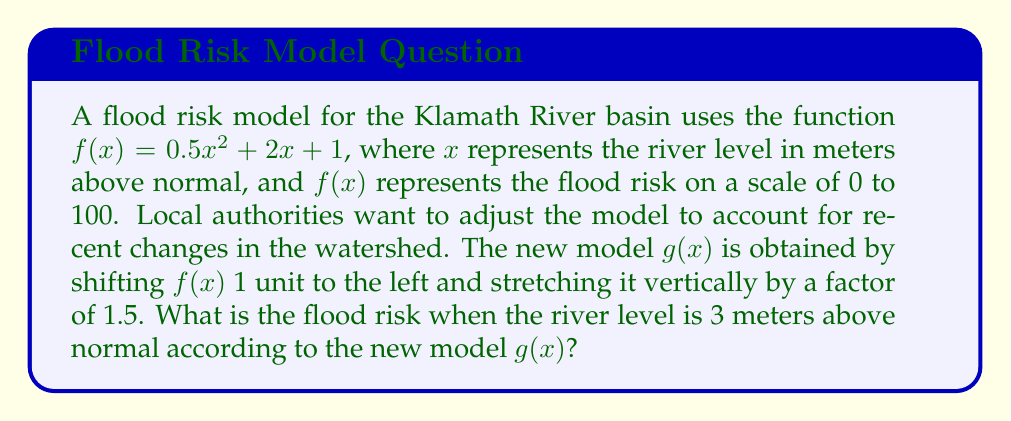Solve this math problem. Let's approach this step-by-step:

1) The original function is $f(x) = 0.5x^2 + 2x + 1$

2) To shift the function 1 unit to the left, we replace $x$ with $(x+1)$:
   $f(x+1) = 0.5(x+1)^2 + 2(x+1) + 1$

3) To stretch it vertically by a factor of 1.5, we multiply the entire function by 1.5:
   $g(x) = 1.5[f(x+1)] = 1.5[0.5(x+1)^2 + 2(x+1) + 1]$

4) Let's expand this:
   $g(x) = 1.5[0.5(x^2 + 2x + 1) + 2x + 2 + 1]$
   $g(x) = 1.5[0.5x^2 + x + 0.5 + 2x + 2 + 1]$
   $g(x) = 1.5[0.5x^2 + 3x + 3.5]$

5) Simplifying:
   $g(x) = 0.75x^2 + 4.5x + 5.25$

6) Now, we need to find $g(3)$:
   $g(3) = 0.75(3)^2 + 4.5(3) + 5.25$
   $g(3) = 0.75(9) + 13.5 + 5.25$
   $g(3) = 6.75 + 13.5 + 5.25$
   $g(3) = 25.5$

Therefore, when the river level is 3 meters above normal, the flood risk according to the new model is 25.5 on a scale of 0 to 100.
Answer: 25.5 